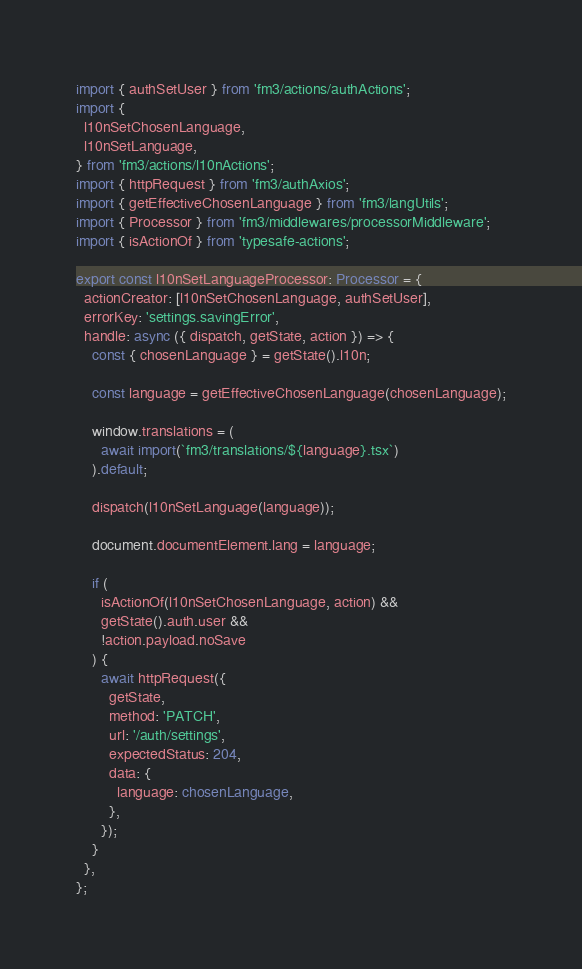<code> <loc_0><loc_0><loc_500><loc_500><_TypeScript_>import { authSetUser } from 'fm3/actions/authActions';
import {
  l10nSetChosenLanguage,
  l10nSetLanguage,
} from 'fm3/actions/l10nActions';
import { httpRequest } from 'fm3/authAxios';
import { getEffectiveChosenLanguage } from 'fm3/langUtils';
import { Processor } from 'fm3/middlewares/processorMiddleware';
import { isActionOf } from 'typesafe-actions';

export const l10nSetLanguageProcessor: Processor = {
  actionCreator: [l10nSetChosenLanguage, authSetUser],
  errorKey: 'settings.savingError',
  handle: async ({ dispatch, getState, action }) => {
    const { chosenLanguage } = getState().l10n;

    const language = getEffectiveChosenLanguage(chosenLanguage);

    window.translations = (
      await import(`fm3/translations/${language}.tsx`)
    ).default;

    dispatch(l10nSetLanguage(language));

    document.documentElement.lang = language;

    if (
      isActionOf(l10nSetChosenLanguage, action) &&
      getState().auth.user &&
      !action.payload.noSave
    ) {
      await httpRequest({
        getState,
        method: 'PATCH',
        url: '/auth/settings',
        expectedStatus: 204,
        data: {
          language: chosenLanguage,
        },
      });
    }
  },
};
</code> 